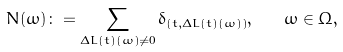Convert formula to latex. <formula><loc_0><loc_0><loc_500><loc_500>N ( \omega ) \colon = \sum _ { \Delta L ( t ) ( \omega ) \neq 0 } \delta _ { ( t , \Delta L ( t ) ( \omega ) ) } , \quad \omega \in \Omega ,</formula> 